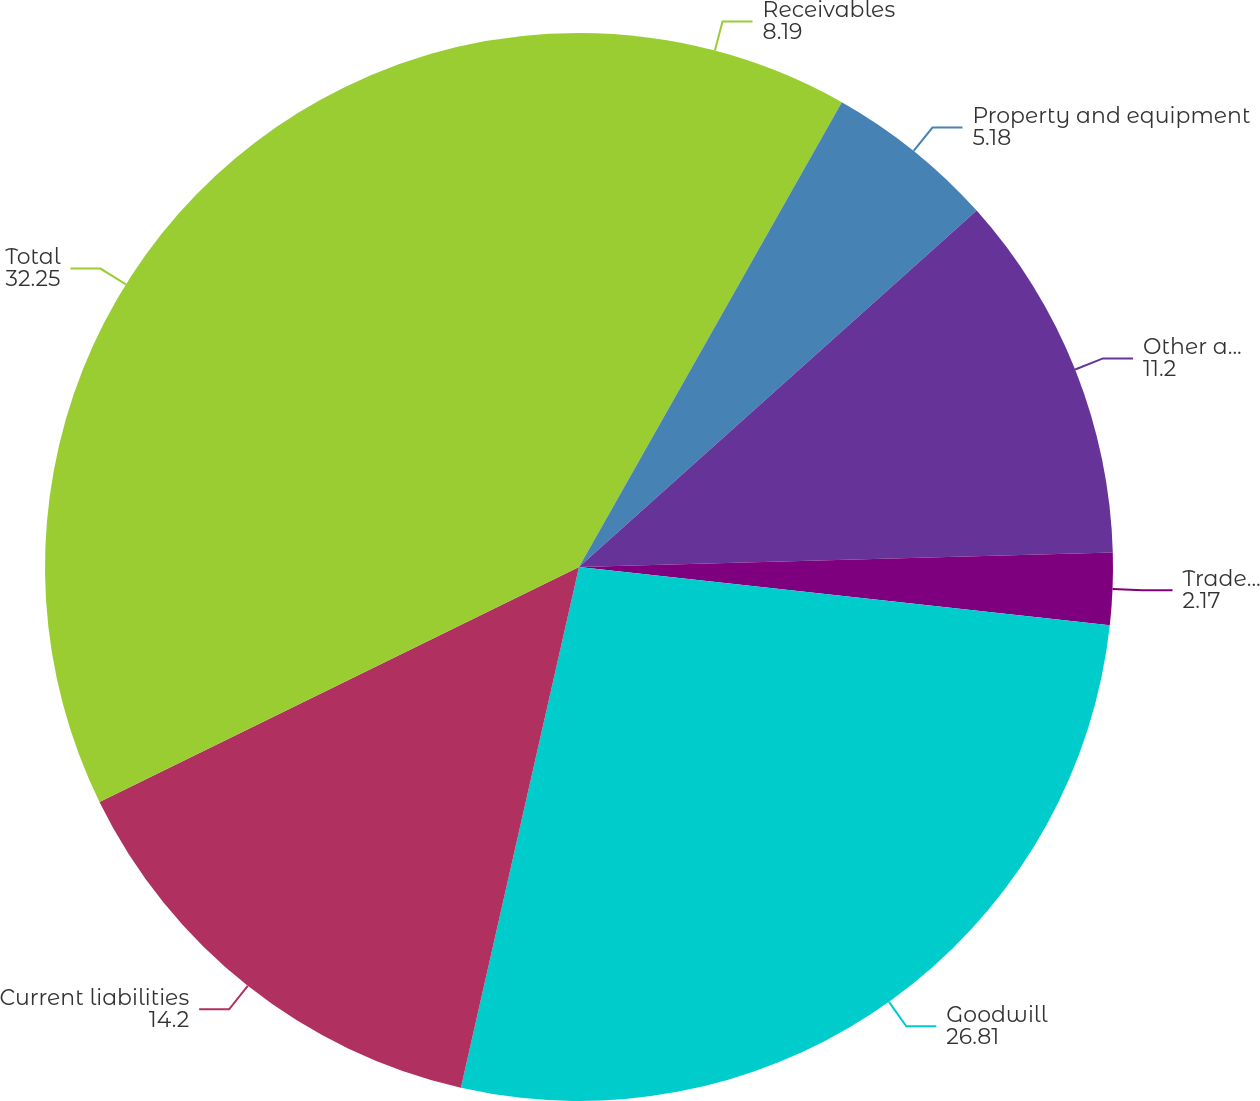Convert chart to OTSL. <chart><loc_0><loc_0><loc_500><loc_500><pie_chart><fcel>Receivables<fcel>Property and equipment<fcel>Other assets<fcel>Tradename<fcel>Goodwill<fcel>Current liabilities<fcel>Total<nl><fcel>8.19%<fcel>5.18%<fcel>11.2%<fcel>2.17%<fcel>26.81%<fcel>14.2%<fcel>32.25%<nl></chart> 